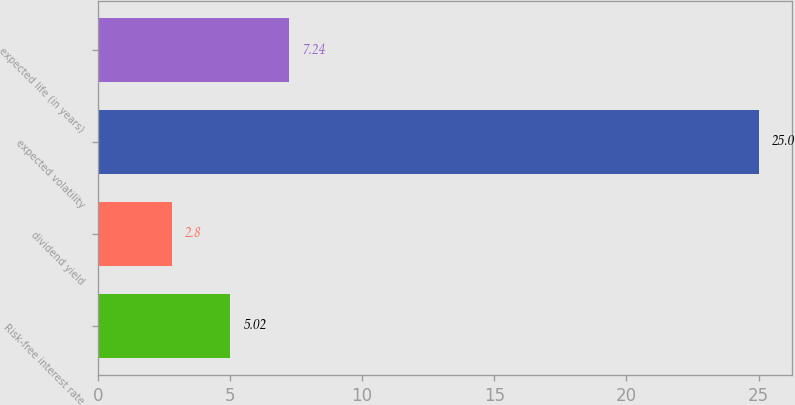Convert chart. <chart><loc_0><loc_0><loc_500><loc_500><bar_chart><fcel>Risk-free interest rate<fcel>dividend yield<fcel>expected volatility<fcel>expected life (in years)<nl><fcel>5.02<fcel>2.8<fcel>25<fcel>7.24<nl></chart> 